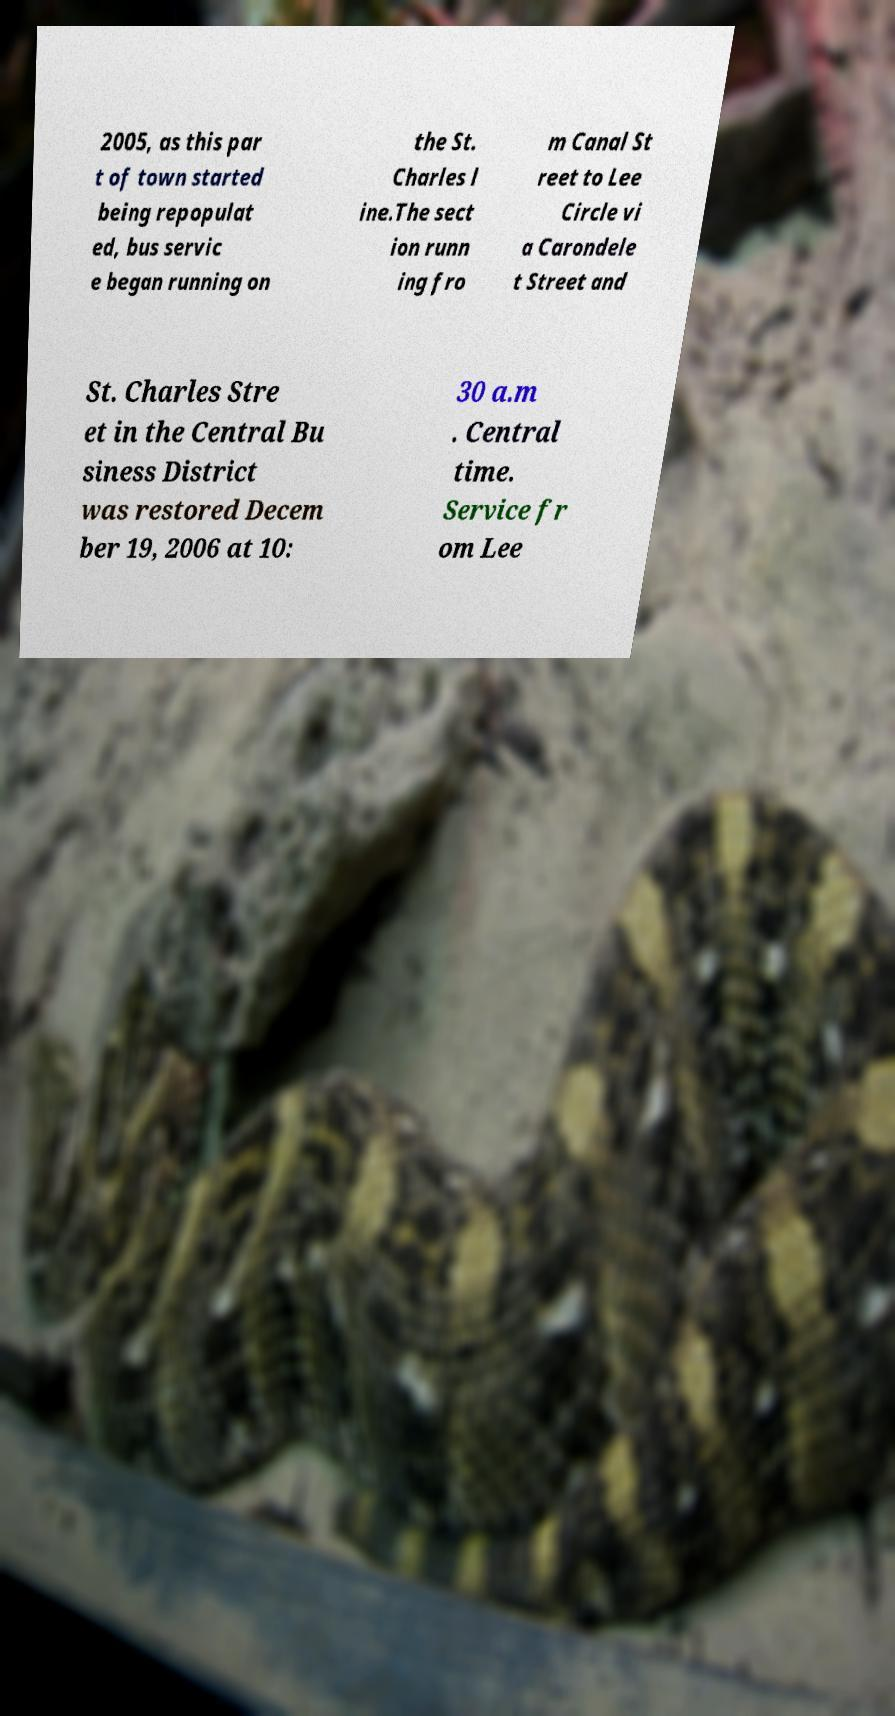I need the written content from this picture converted into text. Can you do that? 2005, as this par t of town started being repopulat ed, bus servic e began running on the St. Charles l ine.The sect ion runn ing fro m Canal St reet to Lee Circle vi a Carondele t Street and St. Charles Stre et in the Central Bu siness District was restored Decem ber 19, 2006 at 10: 30 a.m . Central time. Service fr om Lee 